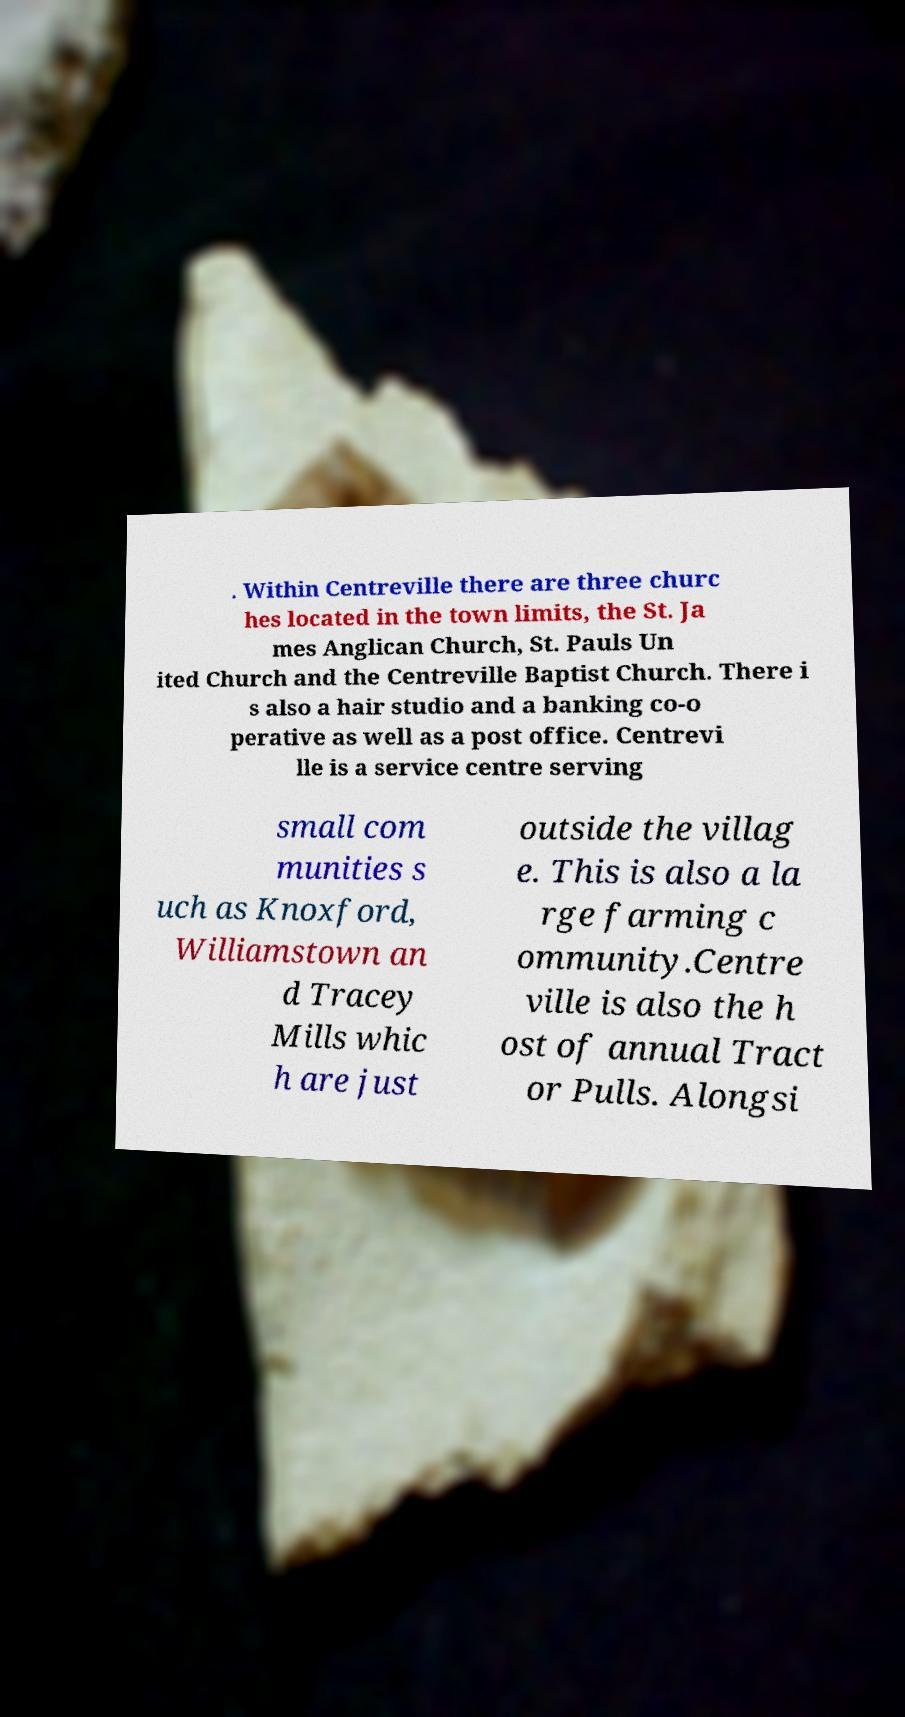Can you read and provide the text displayed in the image?This photo seems to have some interesting text. Can you extract and type it out for me? . Within Centreville there are three churc hes located in the town limits, the St. Ja mes Anglican Church, St. Pauls Un ited Church and the Centreville Baptist Church. There i s also a hair studio and a banking co-o perative as well as a post office. Centrevi lle is a service centre serving small com munities s uch as Knoxford, Williamstown an d Tracey Mills whic h are just outside the villag e. This is also a la rge farming c ommunity.Centre ville is also the h ost of annual Tract or Pulls. Alongsi 